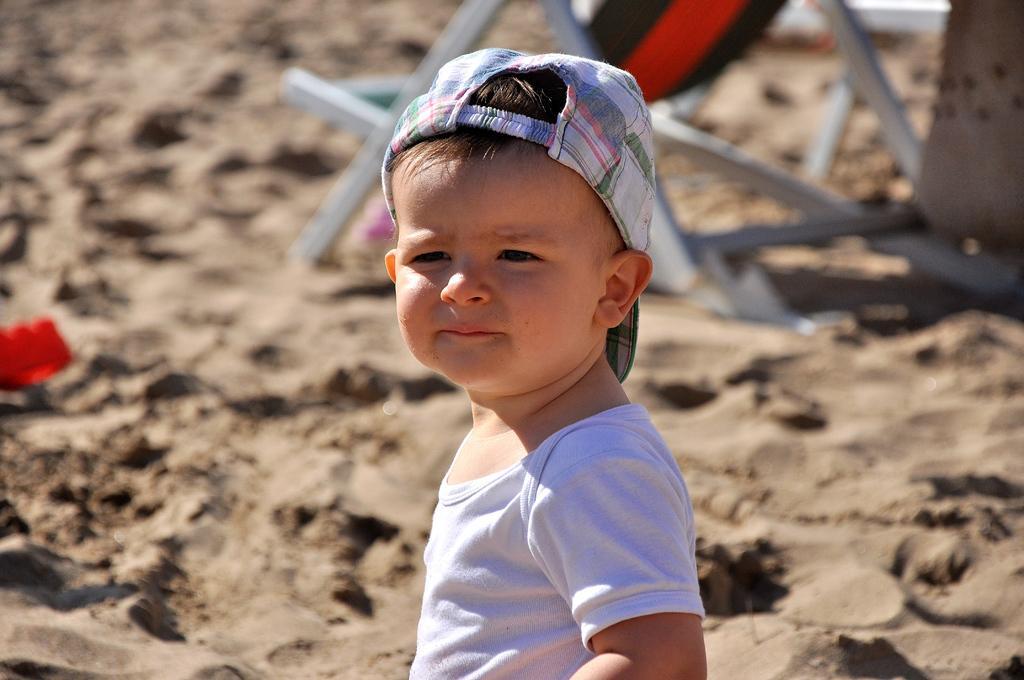How would you summarize this image in a sentence or two? In this image I can see a child wearing white t shirt and cap. In the background I can see a chair which is white, black and red in color on the sand and a red colored object. 